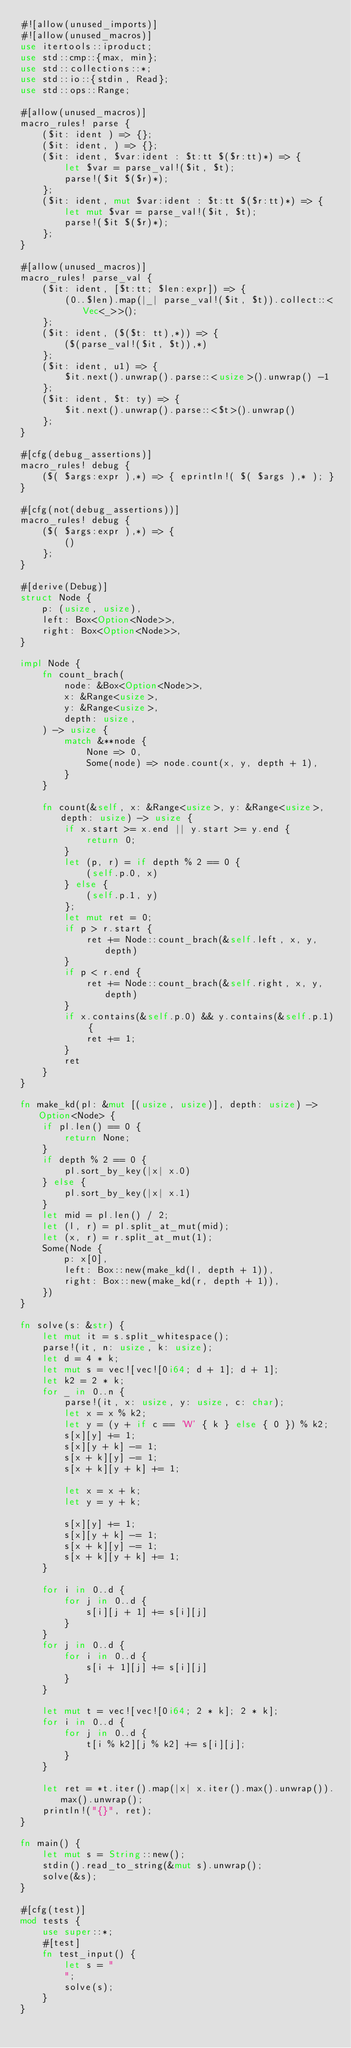<code> <loc_0><loc_0><loc_500><loc_500><_Rust_>#![allow(unused_imports)]
#![allow(unused_macros)]
use itertools::iproduct;
use std::cmp::{max, min};
use std::collections::*;
use std::io::{stdin, Read};
use std::ops::Range;

#[allow(unused_macros)]
macro_rules! parse {
    ($it: ident ) => {};
    ($it: ident, ) => {};
    ($it: ident, $var:ident : $t:tt $($r:tt)*) => {
        let $var = parse_val!($it, $t);
        parse!($it $($r)*);
    };
    ($it: ident, mut $var:ident : $t:tt $($r:tt)*) => {
        let mut $var = parse_val!($it, $t);
        parse!($it $($r)*);
    };
}

#[allow(unused_macros)]
macro_rules! parse_val {
    ($it: ident, [$t:tt; $len:expr]) => {
        (0..$len).map(|_| parse_val!($it, $t)).collect::<Vec<_>>();
    };
    ($it: ident, ($($t: tt),*)) => {
        ($(parse_val!($it, $t)),*)
    };
    ($it: ident, u1) => {
        $it.next().unwrap().parse::<usize>().unwrap() -1
    };
    ($it: ident, $t: ty) => {
        $it.next().unwrap().parse::<$t>().unwrap()
    };
}

#[cfg(debug_assertions)]
macro_rules! debug {
    ($( $args:expr ),*) => { eprintln!( $( $args ),* ); }
}

#[cfg(not(debug_assertions))]
macro_rules! debug {
    ($( $args:expr ),*) => {
        ()
    };
}

#[derive(Debug)]
struct Node {
    p: (usize, usize),
    left: Box<Option<Node>>,
    right: Box<Option<Node>>,
}

impl Node {
    fn count_brach(
        node: &Box<Option<Node>>,
        x: &Range<usize>,
        y: &Range<usize>,
        depth: usize,
    ) -> usize {
        match &**node {
            None => 0,
            Some(node) => node.count(x, y, depth + 1),
        }
    }

    fn count(&self, x: &Range<usize>, y: &Range<usize>, depth: usize) -> usize {
        if x.start >= x.end || y.start >= y.end {
            return 0;
        }
        let (p, r) = if depth % 2 == 0 {
            (self.p.0, x)
        } else {
            (self.p.1, y)
        };
        let mut ret = 0;
        if p > r.start {
            ret += Node::count_brach(&self.left, x, y, depth)
        }
        if p < r.end {
            ret += Node::count_brach(&self.right, x, y, depth)
        }
        if x.contains(&self.p.0) && y.contains(&self.p.1) {
            ret += 1;
        }
        ret
    }
}

fn make_kd(pl: &mut [(usize, usize)], depth: usize) -> Option<Node> {
    if pl.len() == 0 {
        return None;
    }
    if depth % 2 == 0 {
        pl.sort_by_key(|x| x.0)
    } else {
        pl.sort_by_key(|x| x.1)
    }
    let mid = pl.len() / 2;
    let (l, r) = pl.split_at_mut(mid);
    let (x, r) = r.split_at_mut(1);
    Some(Node {
        p: x[0],
        left: Box::new(make_kd(l, depth + 1)),
        right: Box::new(make_kd(r, depth + 1)),
    })
}

fn solve(s: &str) {
    let mut it = s.split_whitespace();
    parse!(it, n: usize, k: usize);
    let d = 4 * k;
    let mut s = vec![vec![0i64; d + 1]; d + 1];
    let k2 = 2 * k;
    for _ in 0..n {
        parse!(it, x: usize, y: usize, c: char);
        let x = x % k2;
        let y = (y + if c == 'W' { k } else { 0 }) % k2;
        s[x][y] += 1;
        s[x][y + k] -= 1;
        s[x + k][y] -= 1;
        s[x + k][y + k] += 1;

        let x = x + k;
        let y = y + k;

        s[x][y] += 1;
        s[x][y + k] -= 1;
        s[x + k][y] -= 1;
        s[x + k][y + k] += 1;
    }

    for i in 0..d {
        for j in 0..d {
            s[i][j + 1] += s[i][j]
        }
    }
    for j in 0..d {
        for i in 0..d {
            s[i + 1][j] += s[i][j]
        }
    }

    let mut t = vec![vec![0i64; 2 * k]; 2 * k];
    for i in 0..d {
        for j in 0..d {
            t[i % k2][j % k2] += s[i][j];
        }
    }

    let ret = *t.iter().map(|x| x.iter().max().unwrap()).max().unwrap();
    println!("{}", ret);
}

fn main() {
    let mut s = String::new();
    stdin().read_to_string(&mut s).unwrap();
    solve(&s);
}

#[cfg(test)]
mod tests {
    use super::*;
    #[test]
    fn test_input() {
        let s = "
        ";
        solve(s);
    }
}
</code> 